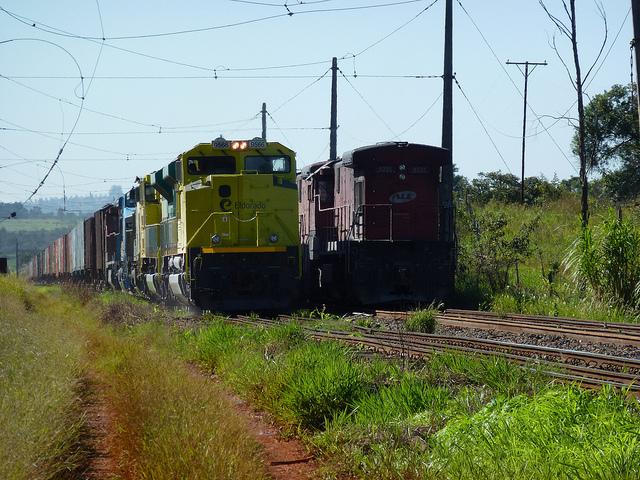How many train tracks are shown?
Write a very short answer. 2. Is the grass trimmed?
Give a very brief answer. No. What color is the front car on the left?
Be succinct. Green. 